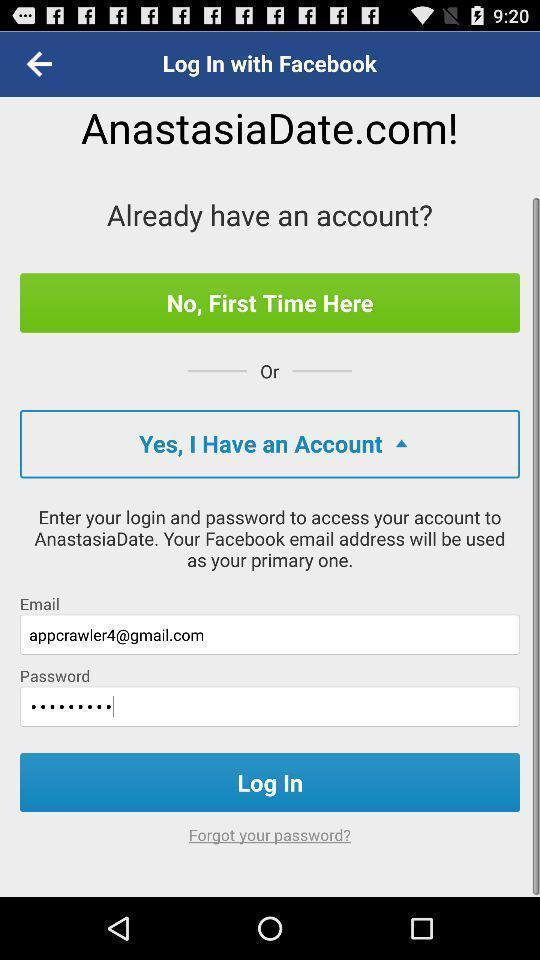What is the overall content of this screenshot? Page showing login page. 